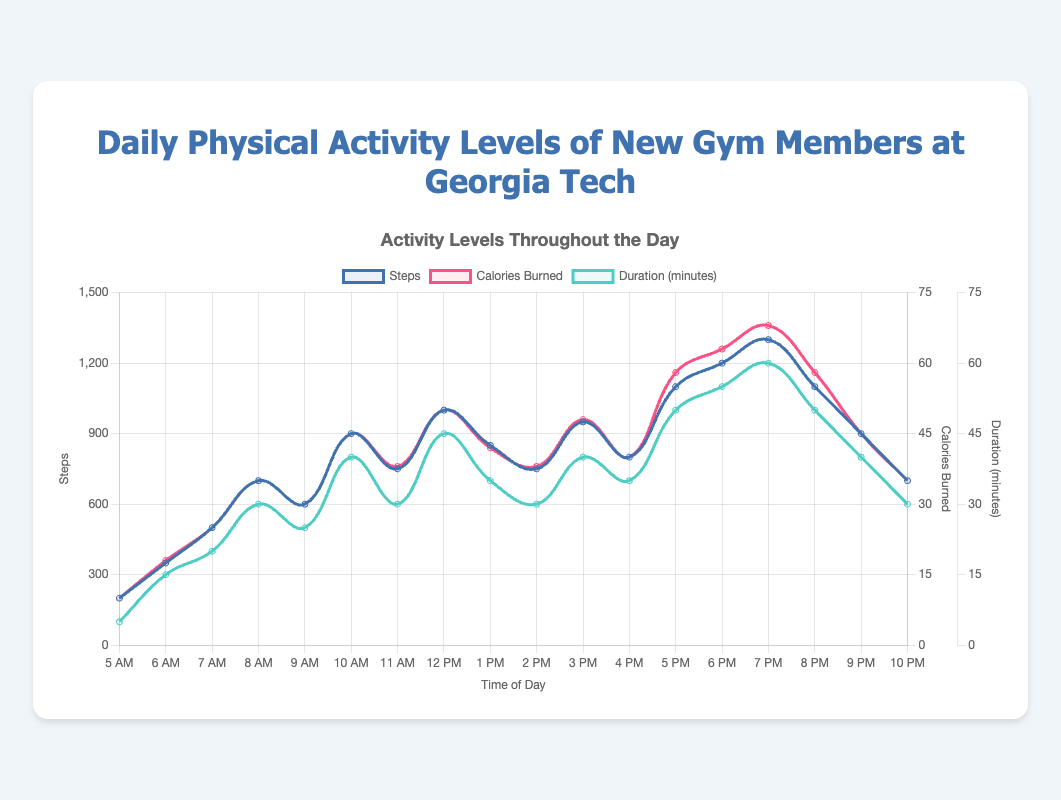What time of day shows the highest number of steps taken? Looking at the curve representing "Steps" on the plot, the highest peak point is at 7 PM with 1300 steps.
Answer: 7 PM How many more steps were taken at 6 PM compared to 6 AM? From the chart, the steps at 6 PM were 1200, and at 6 AM, it was 350. Calculating the difference: 1200 - 350 = 850 steps.
Answer: 850 steps Which hour had the highest calories burned and what was the value? The line representing "Calories Burned" shows its highest point at 7 PM with a value of 68 calories.
Answer: 7 PM, 68 calories What is the difference between the maximum and minimum duration of physical activity throughout the day? The highest duration is 60 minutes at 7 PM, and the lowest is 5 minutes at 5 AM. The difference is 60 - 5 = 55 minutes.
Answer: 55 minutes During which hours do the steps count exceed 1000? Observing the "Steps" line, it exceeds 1000 during the hours of 12 PM, 5 PM, 6 PM, 7 PM, and 8 PM.
Answer: 12 PM, 5 PM, 6 PM, 7 PM, 8 PM Compare the calories burned at 10 AM and 4 PM. Which hour has a higher value and by how much? At 10 AM, calories burned are 45, and at 4 PM, it is 40. The difference is 45 - 40 = 5 calories higher at 10 AM.
Answer: 10 AM, 5 calories What is the average number of steps taken between 1 PM and 3 PM? Steps at 1 PM = 850, at 2 PM = 750, and at 3 PM = 950. The average is (850 + 750 + 950) / 3 = 850 steps.
Answer: 850 steps Which line on the chart reaches its maximum value the earliest in the day, and at what hour? Examining the highest points across all lines, "Duration (minutes)" reaches 30 at 8 AM, the earliest compared to maxima of "Steps" and "Calories Burned" which appear later in the day.
Answer: Duration (minutes), 8 AM What's the total number of steps taken from 5 AM to 11 AM? Summing the steps between 5 AM and 11 AM: 200 + 350 + 500 + 700 + 600 + 900 + 750 = 4000 steps.
Answer: 4000 steps How does the steps count at 3 PM compare to the count at 4 PM? The steps count at 3 PM is 950, whereas at 4 PM it's 800. So, the 3 PM count is higher by 950 - 800 = 150 steps.
Answer: 3 PM, 150 steps 